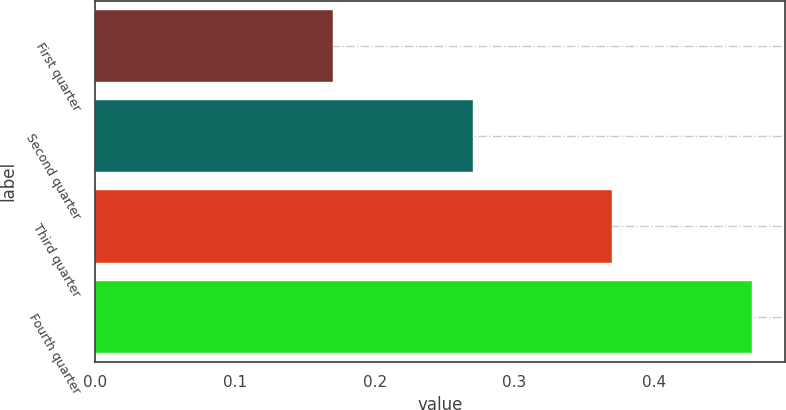Convert chart to OTSL. <chart><loc_0><loc_0><loc_500><loc_500><bar_chart><fcel>First quarter<fcel>Second quarter<fcel>Third quarter<fcel>Fourth quarter<nl><fcel>0.17<fcel>0.27<fcel>0.37<fcel>0.47<nl></chart> 